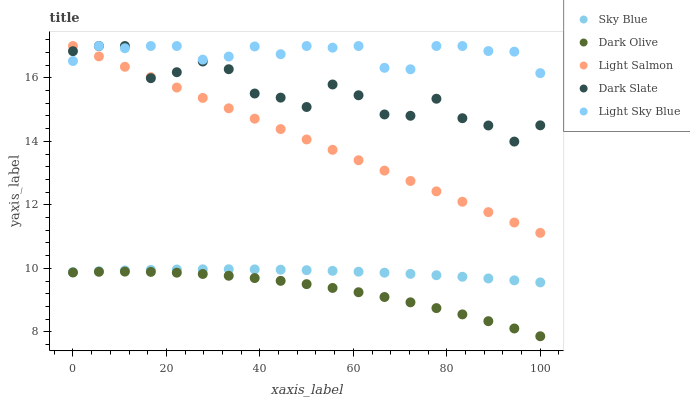Does Dark Olive have the minimum area under the curve?
Answer yes or no. Yes. Does Light Sky Blue have the maximum area under the curve?
Answer yes or no. Yes. Does Light Salmon have the minimum area under the curve?
Answer yes or no. No. Does Light Salmon have the maximum area under the curve?
Answer yes or no. No. Is Light Salmon the smoothest?
Answer yes or no. Yes. Is Dark Slate the roughest?
Answer yes or no. Yes. Is Dark Olive the smoothest?
Answer yes or no. No. Is Dark Olive the roughest?
Answer yes or no. No. Does Dark Olive have the lowest value?
Answer yes or no. Yes. Does Light Salmon have the lowest value?
Answer yes or no. No. Does Dark Slate have the highest value?
Answer yes or no. Yes. Does Dark Olive have the highest value?
Answer yes or no. No. Is Sky Blue less than Dark Slate?
Answer yes or no. Yes. Is Light Sky Blue greater than Sky Blue?
Answer yes or no. Yes. Does Light Sky Blue intersect Dark Slate?
Answer yes or no. Yes. Is Light Sky Blue less than Dark Slate?
Answer yes or no. No. Is Light Sky Blue greater than Dark Slate?
Answer yes or no. No. Does Sky Blue intersect Dark Slate?
Answer yes or no. No. 